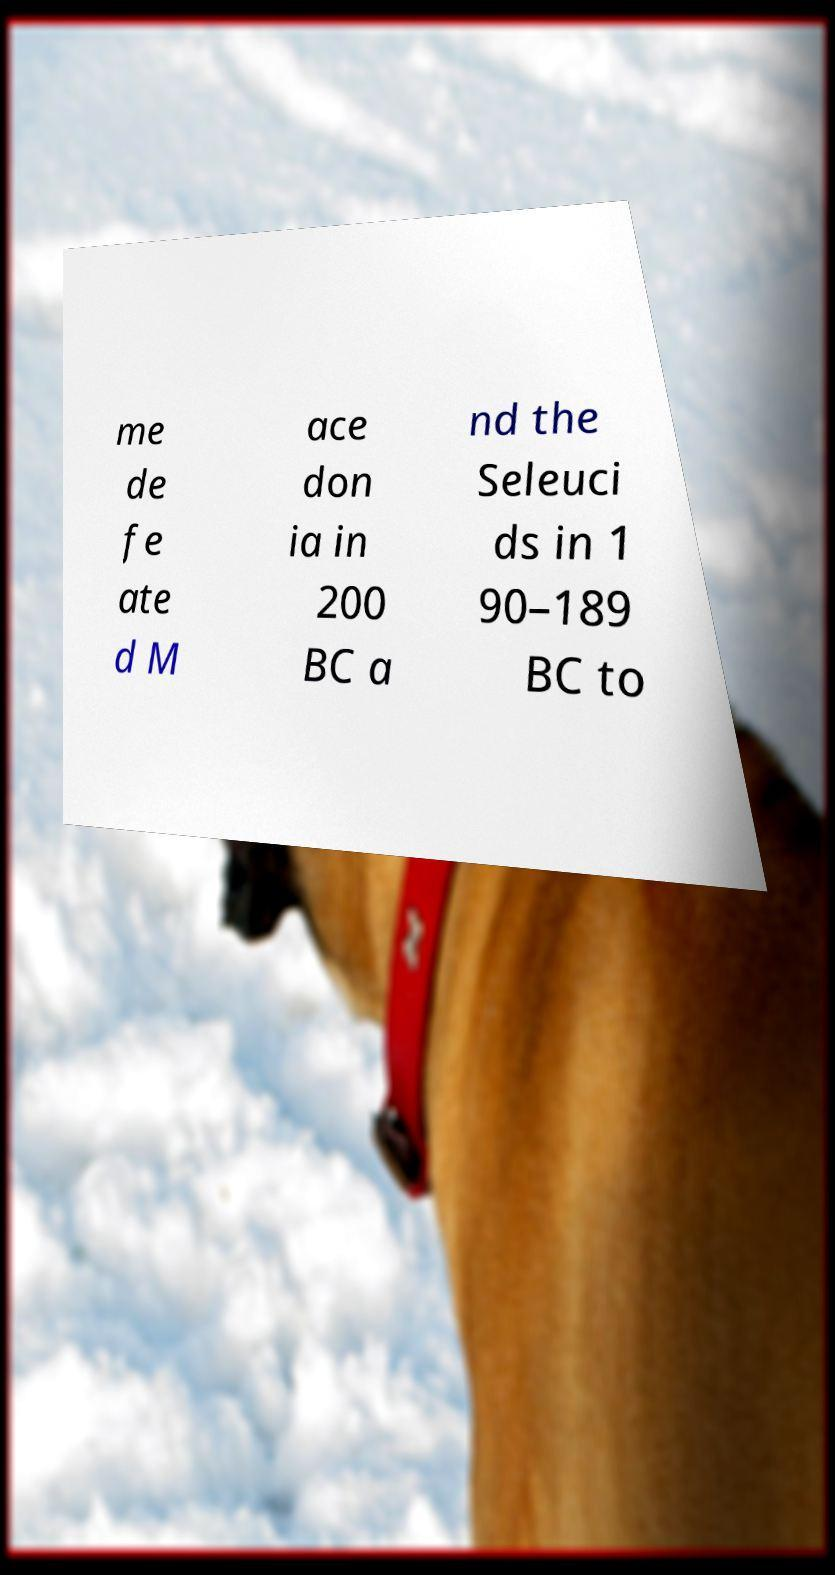Please identify and transcribe the text found in this image. me de fe ate d M ace don ia in 200 BC a nd the Seleuci ds in 1 90–189 BC to 